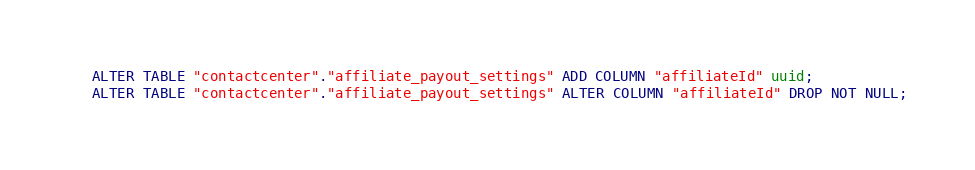Convert code to text. <code><loc_0><loc_0><loc_500><loc_500><_SQL_>ALTER TABLE "contactcenter"."affiliate_payout_settings" ADD COLUMN "affiliateId" uuid;
ALTER TABLE "contactcenter"."affiliate_payout_settings" ALTER COLUMN "affiliateId" DROP NOT NULL;
</code> 